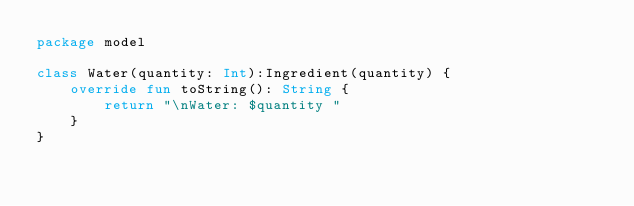<code> <loc_0><loc_0><loc_500><loc_500><_Kotlin_>package model

class Water(quantity: Int):Ingredient(quantity) {
    override fun toString(): String {
        return "\nWater: $quantity "
    }
}</code> 